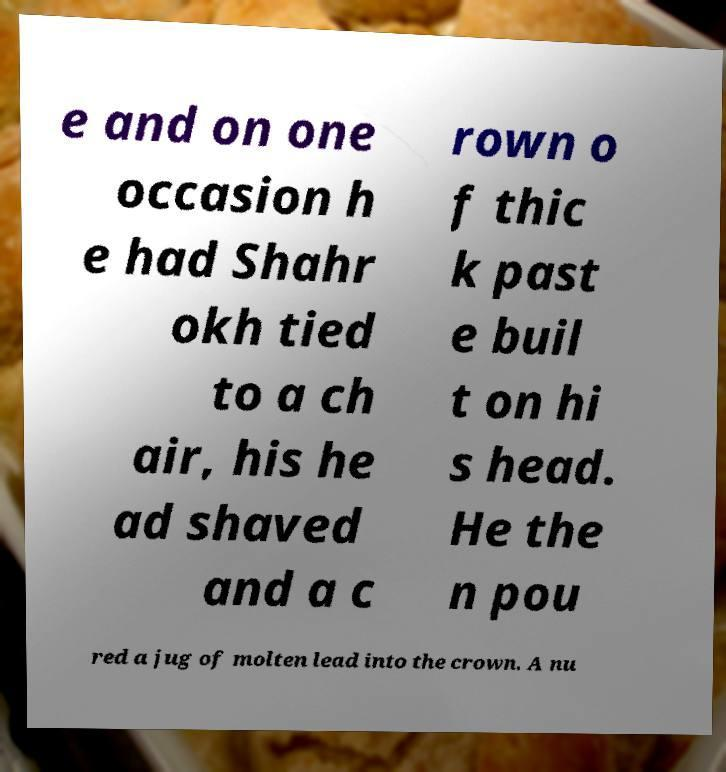What messages or text are displayed in this image? I need them in a readable, typed format. e and on one occasion h e had Shahr okh tied to a ch air, his he ad shaved and a c rown o f thic k past e buil t on hi s head. He the n pou red a jug of molten lead into the crown. A nu 